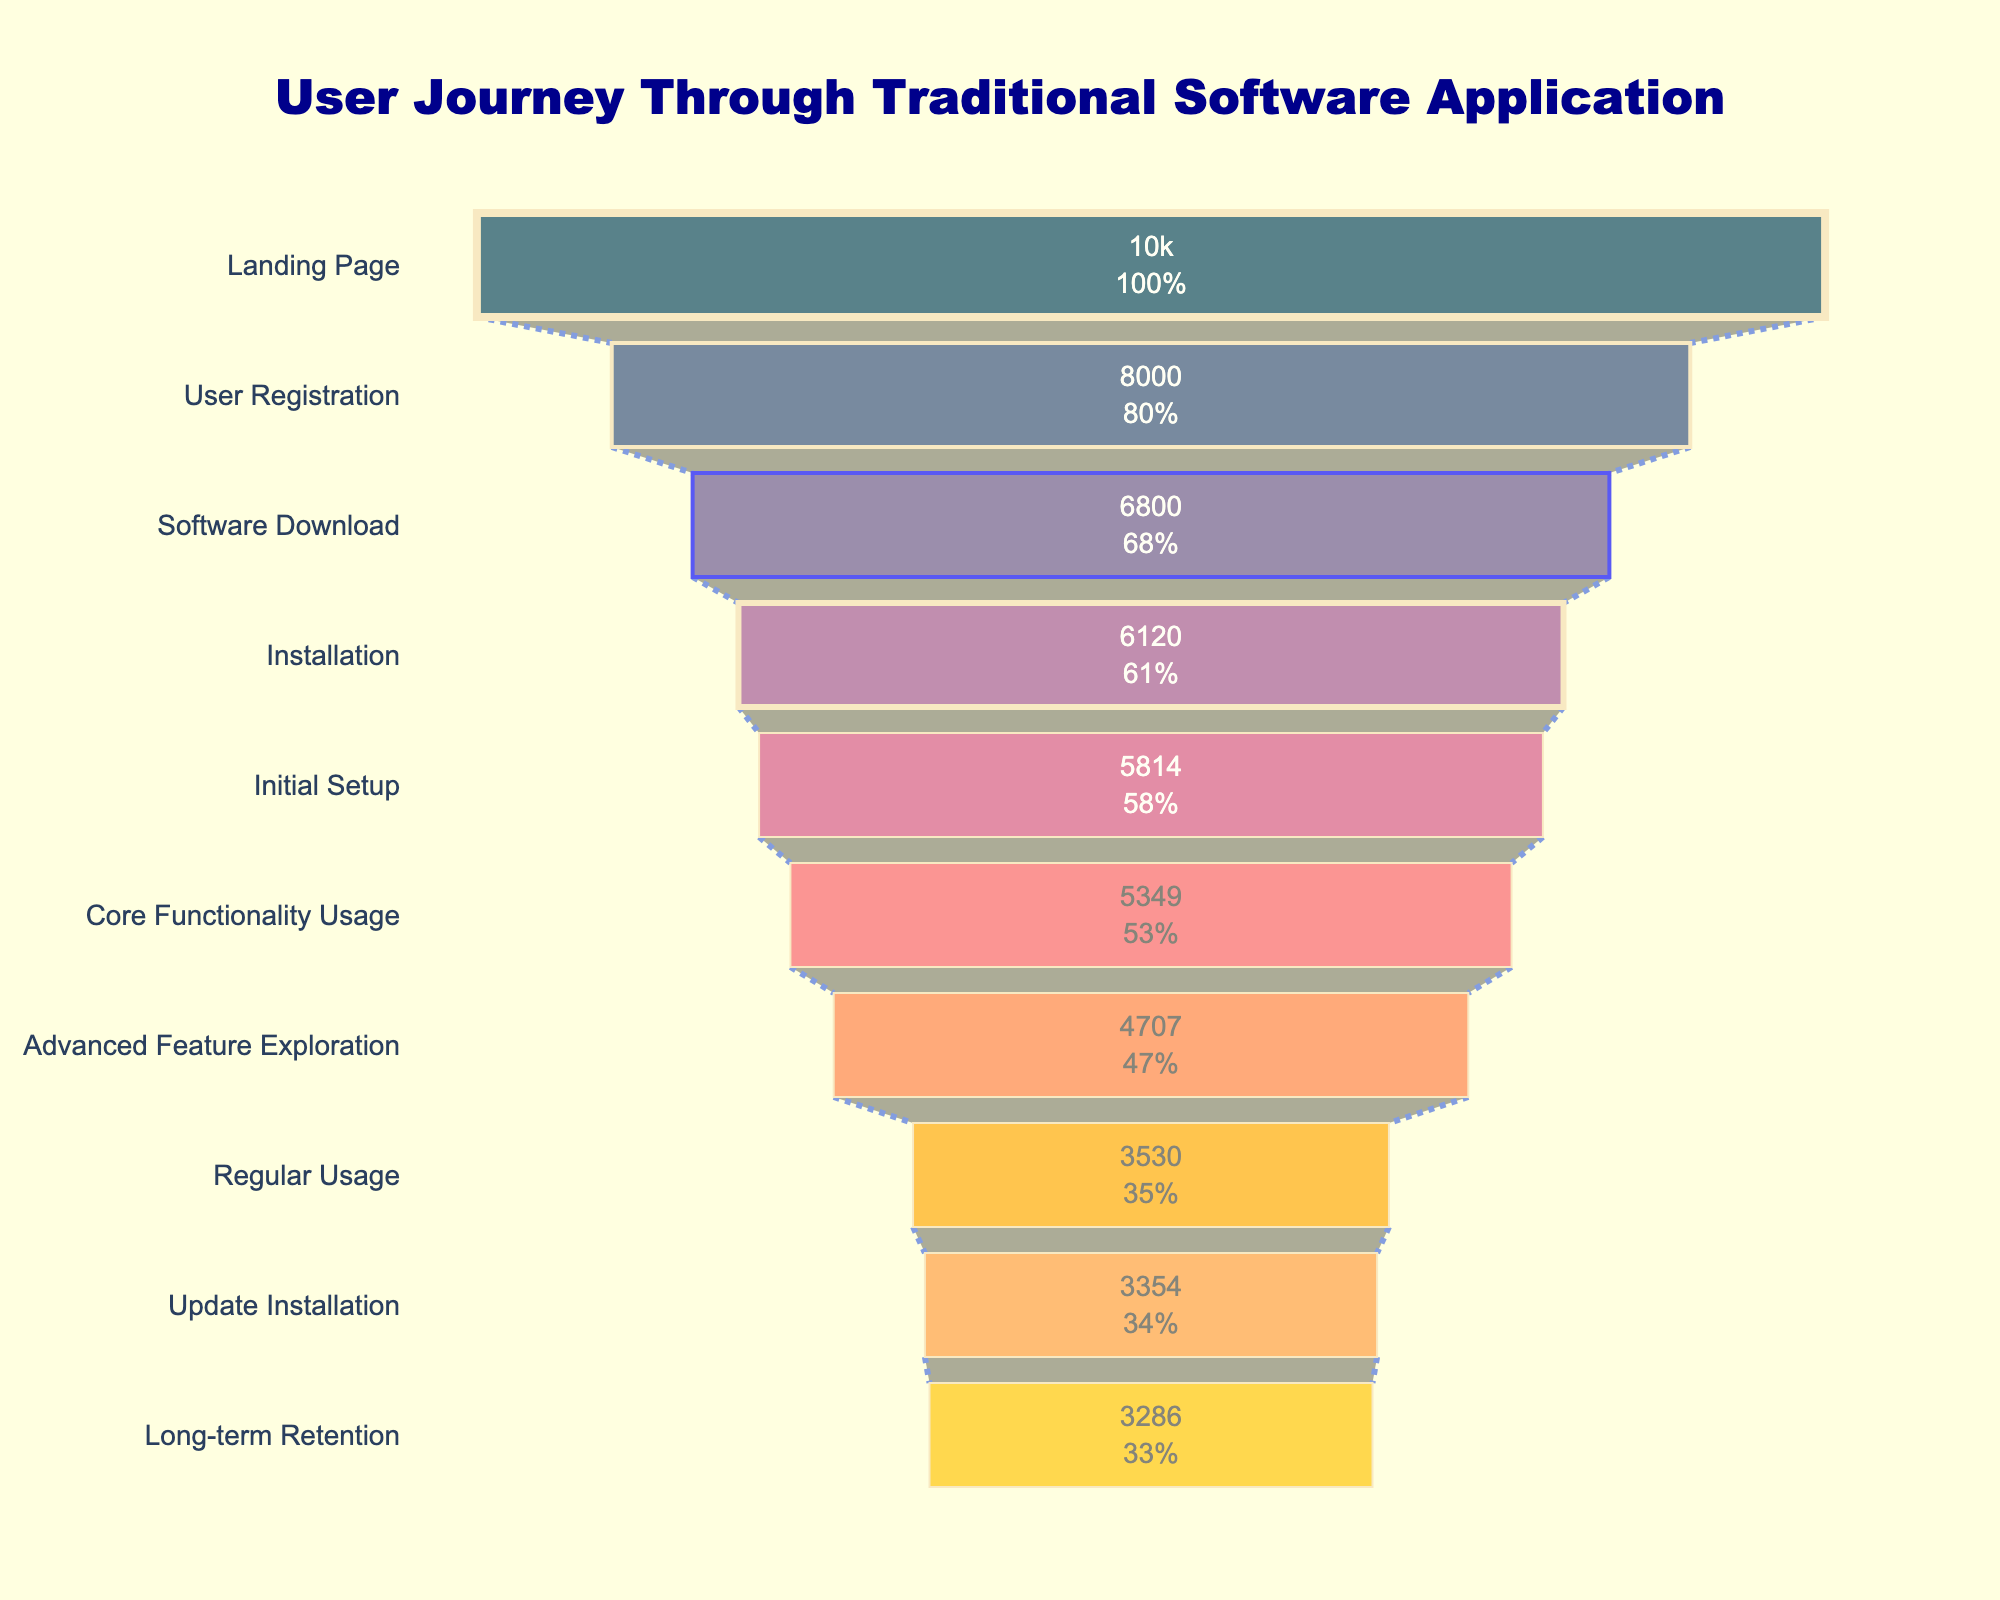How many users started at the landing page? The title of the figure is "User Journey Through Traditional Software Application" and the first step in the funnel chart is "Landing Page" with the value shown inside the bar. By looking inside the first bar, we see that the number of users is 10000.
Answer: 10000 What is the dropout rate at the Core Functionality Usage step? The figure lists the dropout rates directly in the bars. To find the dropout rate at "Core Functionality Usage," look at the position corresponding to this step in the funnel and note the wording or value indicating the dropout rate. The dropout rate for "Core Functionality Usage" is 12%.
Answer: 12% Which step has the highest dropout rate? By scanning through all the steps in the funnel chart and comparing the dropout rates listed within each bar, you will find that "Advanced Feature Exploration" has the highest dropout rate at 25%.
Answer: Advanced Feature Exploration How many users actually use core functionality after all previous steps? Starting from the initial number of users (10000 at the Landing Page), we apply the dropout rate successively for each prior step until "Core Functionality Usage". (10000 * 0.8 for Landing Page) => 8000 users, (8000 * 0.85 for User Registration) => 6800 users, (6800 * 0.9 for Software Download) => 6120 users, (6120 * 0.95 for Installation) => 5814 users, (5814 * 0.92 for Initial Setup) => 5349 users. Thus, 5349 users actually use the core functionality.
Answer: 5349 What is the total number of users who drop off by the Regular Usage step? To find the total dropout, we need to sum all dropped users in each intermediary step until "Regular Usage". For each step, calculate the difference due to dropout: Landing Page (10000 - 8000) = 2000, User Registration (8000 - 6800) = 1200, Software Download (6800 - 6120) = 680, Installation (6120 - 5814) = 306, Initial Setup (5814 - 5349) = 465, Core Functionality Usage (5349 - 4707) = 642, and Advanced Feature Exploration (4707 - 3530) = 1177. Summing these dropouts gives 2000 + 1200 + 680 + 306 + 465 + 642 + 1177 = 6470 users.
Answer: 6470 What proportion of users remain at the Long-term Retention step compared to the Landing Page? To determine the proportion of retained users at the "Long-term Retention" step relative to the "Landing Page", divide the number of users at the Retention step by the number of users who started at the landing page: (3286 / 10000) = 0.3286 or approximately 32.86%.
Answer: 32.86% What step has the smallest number of users remaining? Checking the bottom of the funnel chart, the last step "Long-term Retention" shows the number of users as 3286, which is indeed the lowest number among all steps as shown visually in the chart.
Answer: Long-term Retention Is the dropout rate higher during "Initial Setup" or at "Update Installation"? Locate the dropout rates for both "Initial Setup" and "Update Installation". The dropout rate for "Initial Setup" is 8%, and for "Update Installation", it is 2%. Comparing both, the dropout rate is higher for "Initial Setup".
Answer: Initial Setup How many steps are included in the user journey through this traditional software application? By counting the distinct steps listed in the funnel chart from the beginning to the end, we note 10 steps in total.
Answer: 10 